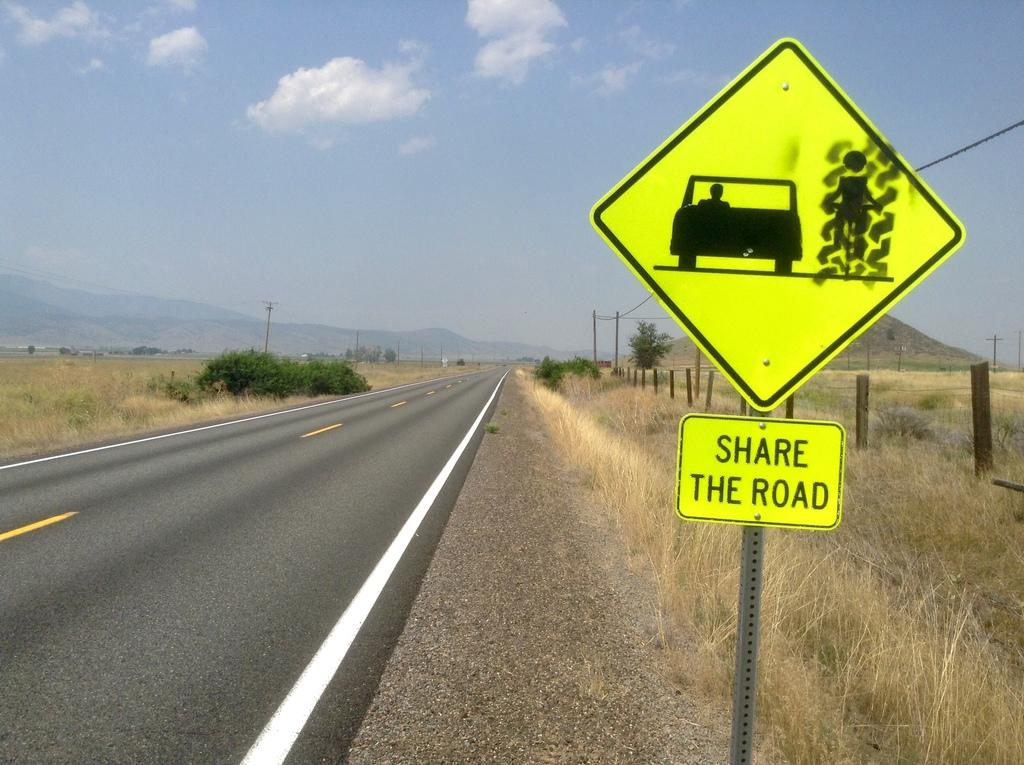Provide a one-sentence caption for the provided image. share the road sign of a vehicle and a person to the right of them next to a road in the country side. 